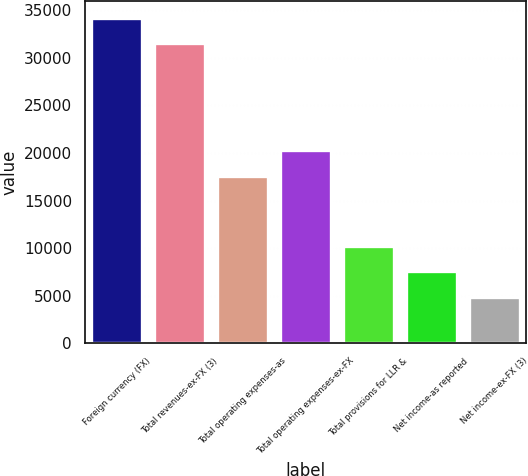Convert chart to OTSL. <chart><loc_0><loc_0><loc_500><loc_500><bar_chart><fcel>Foreign currency (FX)<fcel>Total revenues-ex-FX (3)<fcel>Total operating expenses-as<fcel>Total operating expenses-ex-FX<fcel>Total provisions for LLR &<fcel>Net income-as reported<fcel>Net income-ex-FX (3)<nl><fcel>34241.9<fcel>31570<fcel>17627<fcel>20298.9<fcel>10248.8<fcel>7576.9<fcel>4905<nl></chart> 